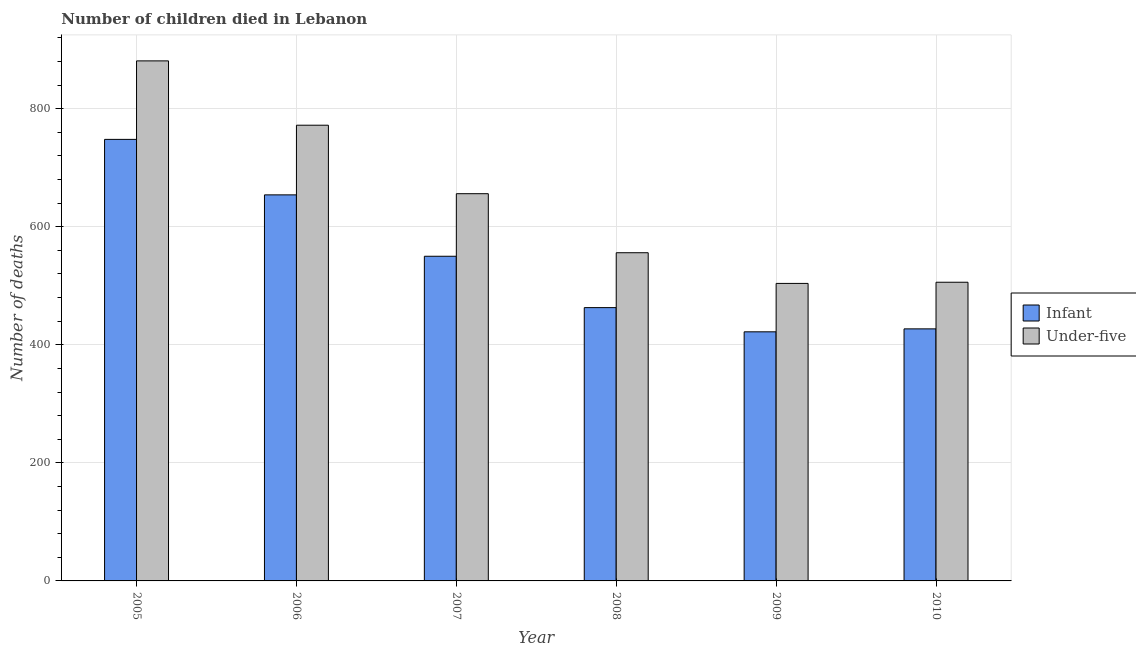How many groups of bars are there?
Make the answer very short. 6. Are the number of bars per tick equal to the number of legend labels?
Make the answer very short. Yes. What is the number of infant deaths in 2010?
Make the answer very short. 427. Across all years, what is the maximum number of infant deaths?
Your answer should be compact. 748. Across all years, what is the minimum number of under-five deaths?
Make the answer very short. 504. In which year was the number of infant deaths maximum?
Your answer should be very brief. 2005. In which year was the number of infant deaths minimum?
Your answer should be very brief. 2009. What is the total number of under-five deaths in the graph?
Ensure brevity in your answer.  3875. What is the difference between the number of infant deaths in 2005 and that in 2007?
Offer a very short reply. 198. What is the difference between the number of under-five deaths in 2010 and the number of infant deaths in 2007?
Ensure brevity in your answer.  -150. What is the average number of infant deaths per year?
Offer a very short reply. 544. In the year 2010, what is the difference between the number of infant deaths and number of under-five deaths?
Provide a short and direct response. 0. What is the ratio of the number of under-five deaths in 2005 to that in 2008?
Your response must be concise. 1.58. Is the number of under-five deaths in 2006 less than that in 2010?
Your response must be concise. No. What is the difference between the highest and the second highest number of infant deaths?
Keep it short and to the point. 94. What is the difference between the highest and the lowest number of under-five deaths?
Provide a short and direct response. 377. What does the 1st bar from the left in 2006 represents?
Offer a terse response. Infant. What does the 2nd bar from the right in 2008 represents?
Your answer should be very brief. Infant. What is the difference between two consecutive major ticks on the Y-axis?
Make the answer very short. 200. What is the title of the graph?
Make the answer very short. Number of children died in Lebanon. What is the label or title of the X-axis?
Ensure brevity in your answer.  Year. What is the label or title of the Y-axis?
Provide a succinct answer. Number of deaths. What is the Number of deaths in Infant in 2005?
Offer a very short reply. 748. What is the Number of deaths of Under-five in 2005?
Provide a succinct answer. 881. What is the Number of deaths in Infant in 2006?
Offer a terse response. 654. What is the Number of deaths in Under-five in 2006?
Ensure brevity in your answer.  772. What is the Number of deaths of Infant in 2007?
Offer a very short reply. 550. What is the Number of deaths in Under-five in 2007?
Make the answer very short. 656. What is the Number of deaths in Infant in 2008?
Offer a terse response. 463. What is the Number of deaths in Under-five in 2008?
Offer a very short reply. 556. What is the Number of deaths in Infant in 2009?
Provide a short and direct response. 422. What is the Number of deaths in Under-five in 2009?
Provide a succinct answer. 504. What is the Number of deaths of Infant in 2010?
Your answer should be compact. 427. What is the Number of deaths in Under-five in 2010?
Your response must be concise. 506. Across all years, what is the maximum Number of deaths in Infant?
Your answer should be very brief. 748. Across all years, what is the maximum Number of deaths of Under-five?
Ensure brevity in your answer.  881. Across all years, what is the minimum Number of deaths in Infant?
Your answer should be compact. 422. Across all years, what is the minimum Number of deaths of Under-five?
Provide a succinct answer. 504. What is the total Number of deaths of Infant in the graph?
Offer a very short reply. 3264. What is the total Number of deaths in Under-five in the graph?
Make the answer very short. 3875. What is the difference between the Number of deaths of Infant in 2005 and that in 2006?
Your answer should be compact. 94. What is the difference between the Number of deaths in Under-five in 2005 and that in 2006?
Keep it short and to the point. 109. What is the difference between the Number of deaths of Infant in 2005 and that in 2007?
Offer a very short reply. 198. What is the difference between the Number of deaths in Under-five in 2005 and that in 2007?
Your answer should be very brief. 225. What is the difference between the Number of deaths in Infant in 2005 and that in 2008?
Give a very brief answer. 285. What is the difference between the Number of deaths of Under-five in 2005 and that in 2008?
Provide a succinct answer. 325. What is the difference between the Number of deaths of Infant in 2005 and that in 2009?
Ensure brevity in your answer.  326. What is the difference between the Number of deaths in Under-five in 2005 and that in 2009?
Give a very brief answer. 377. What is the difference between the Number of deaths of Infant in 2005 and that in 2010?
Your answer should be very brief. 321. What is the difference between the Number of deaths of Under-five in 2005 and that in 2010?
Your answer should be compact. 375. What is the difference between the Number of deaths in Infant in 2006 and that in 2007?
Ensure brevity in your answer.  104. What is the difference between the Number of deaths in Under-five in 2006 and that in 2007?
Your answer should be very brief. 116. What is the difference between the Number of deaths in Infant in 2006 and that in 2008?
Offer a very short reply. 191. What is the difference between the Number of deaths of Under-five in 2006 and that in 2008?
Provide a succinct answer. 216. What is the difference between the Number of deaths in Infant in 2006 and that in 2009?
Your response must be concise. 232. What is the difference between the Number of deaths in Under-five in 2006 and that in 2009?
Your response must be concise. 268. What is the difference between the Number of deaths in Infant in 2006 and that in 2010?
Make the answer very short. 227. What is the difference between the Number of deaths in Under-five in 2006 and that in 2010?
Keep it short and to the point. 266. What is the difference between the Number of deaths in Under-five in 2007 and that in 2008?
Give a very brief answer. 100. What is the difference between the Number of deaths of Infant in 2007 and that in 2009?
Provide a short and direct response. 128. What is the difference between the Number of deaths in Under-five in 2007 and that in 2009?
Keep it short and to the point. 152. What is the difference between the Number of deaths in Infant in 2007 and that in 2010?
Your answer should be very brief. 123. What is the difference between the Number of deaths in Under-five in 2007 and that in 2010?
Provide a short and direct response. 150. What is the difference between the Number of deaths of Infant in 2008 and that in 2010?
Ensure brevity in your answer.  36. What is the difference between the Number of deaths in Under-five in 2008 and that in 2010?
Provide a short and direct response. 50. What is the difference between the Number of deaths in Under-five in 2009 and that in 2010?
Keep it short and to the point. -2. What is the difference between the Number of deaths in Infant in 2005 and the Number of deaths in Under-five in 2007?
Your response must be concise. 92. What is the difference between the Number of deaths in Infant in 2005 and the Number of deaths in Under-five in 2008?
Your answer should be very brief. 192. What is the difference between the Number of deaths of Infant in 2005 and the Number of deaths of Under-five in 2009?
Provide a short and direct response. 244. What is the difference between the Number of deaths in Infant in 2005 and the Number of deaths in Under-five in 2010?
Offer a terse response. 242. What is the difference between the Number of deaths of Infant in 2006 and the Number of deaths of Under-five in 2007?
Your response must be concise. -2. What is the difference between the Number of deaths of Infant in 2006 and the Number of deaths of Under-five in 2008?
Keep it short and to the point. 98. What is the difference between the Number of deaths in Infant in 2006 and the Number of deaths in Under-five in 2009?
Offer a very short reply. 150. What is the difference between the Number of deaths of Infant in 2006 and the Number of deaths of Under-five in 2010?
Give a very brief answer. 148. What is the difference between the Number of deaths of Infant in 2007 and the Number of deaths of Under-five in 2008?
Your response must be concise. -6. What is the difference between the Number of deaths of Infant in 2008 and the Number of deaths of Under-five in 2009?
Your answer should be very brief. -41. What is the difference between the Number of deaths of Infant in 2008 and the Number of deaths of Under-five in 2010?
Your answer should be very brief. -43. What is the difference between the Number of deaths of Infant in 2009 and the Number of deaths of Under-five in 2010?
Make the answer very short. -84. What is the average Number of deaths of Infant per year?
Provide a succinct answer. 544. What is the average Number of deaths in Under-five per year?
Make the answer very short. 645.83. In the year 2005, what is the difference between the Number of deaths of Infant and Number of deaths of Under-five?
Offer a terse response. -133. In the year 2006, what is the difference between the Number of deaths of Infant and Number of deaths of Under-five?
Your answer should be compact. -118. In the year 2007, what is the difference between the Number of deaths in Infant and Number of deaths in Under-five?
Your answer should be compact. -106. In the year 2008, what is the difference between the Number of deaths in Infant and Number of deaths in Under-five?
Your answer should be compact. -93. In the year 2009, what is the difference between the Number of deaths in Infant and Number of deaths in Under-five?
Make the answer very short. -82. In the year 2010, what is the difference between the Number of deaths of Infant and Number of deaths of Under-five?
Your answer should be compact. -79. What is the ratio of the Number of deaths in Infant in 2005 to that in 2006?
Your answer should be compact. 1.14. What is the ratio of the Number of deaths of Under-five in 2005 to that in 2006?
Ensure brevity in your answer.  1.14. What is the ratio of the Number of deaths of Infant in 2005 to that in 2007?
Keep it short and to the point. 1.36. What is the ratio of the Number of deaths of Under-five in 2005 to that in 2007?
Provide a succinct answer. 1.34. What is the ratio of the Number of deaths of Infant in 2005 to that in 2008?
Keep it short and to the point. 1.62. What is the ratio of the Number of deaths of Under-five in 2005 to that in 2008?
Provide a succinct answer. 1.58. What is the ratio of the Number of deaths in Infant in 2005 to that in 2009?
Make the answer very short. 1.77. What is the ratio of the Number of deaths in Under-five in 2005 to that in 2009?
Offer a very short reply. 1.75. What is the ratio of the Number of deaths of Infant in 2005 to that in 2010?
Keep it short and to the point. 1.75. What is the ratio of the Number of deaths in Under-five in 2005 to that in 2010?
Keep it short and to the point. 1.74. What is the ratio of the Number of deaths in Infant in 2006 to that in 2007?
Offer a terse response. 1.19. What is the ratio of the Number of deaths of Under-five in 2006 to that in 2007?
Offer a terse response. 1.18. What is the ratio of the Number of deaths of Infant in 2006 to that in 2008?
Give a very brief answer. 1.41. What is the ratio of the Number of deaths in Under-five in 2006 to that in 2008?
Ensure brevity in your answer.  1.39. What is the ratio of the Number of deaths in Infant in 2006 to that in 2009?
Ensure brevity in your answer.  1.55. What is the ratio of the Number of deaths in Under-five in 2006 to that in 2009?
Ensure brevity in your answer.  1.53. What is the ratio of the Number of deaths of Infant in 2006 to that in 2010?
Ensure brevity in your answer.  1.53. What is the ratio of the Number of deaths of Under-five in 2006 to that in 2010?
Offer a very short reply. 1.53. What is the ratio of the Number of deaths in Infant in 2007 to that in 2008?
Provide a succinct answer. 1.19. What is the ratio of the Number of deaths of Under-five in 2007 to that in 2008?
Make the answer very short. 1.18. What is the ratio of the Number of deaths of Infant in 2007 to that in 2009?
Make the answer very short. 1.3. What is the ratio of the Number of deaths in Under-five in 2007 to that in 2009?
Your response must be concise. 1.3. What is the ratio of the Number of deaths of Infant in 2007 to that in 2010?
Provide a short and direct response. 1.29. What is the ratio of the Number of deaths in Under-five in 2007 to that in 2010?
Your answer should be very brief. 1.3. What is the ratio of the Number of deaths of Infant in 2008 to that in 2009?
Make the answer very short. 1.1. What is the ratio of the Number of deaths of Under-five in 2008 to that in 2009?
Ensure brevity in your answer.  1.1. What is the ratio of the Number of deaths of Infant in 2008 to that in 2010?
Offer a very short reply. 1.08. What is the ratio of the Number of deaths of Under-five in 2008 to that in 2010?
Keep it short and to the point. 1.1. What is the ratio of the Number of deaths of Infant in 2009 to that in 2010?
Your response must be concise. 0.99. What is the ratio of the Number of deaths of Under-five in 2009 to that in 2010?
Your answer should be compact. 1. What is the difference between the highest and the second highest Number of deaths in Infant?
Provide a succinct answer. 94. What is the difference between the highest and the second highest Number of deaths of Under-five?
Your response must be concise. 109. What is the difference between the highest and the lowest Number of deaths in Infant?
Offer a terse response. 326. What is the difference between the highest and the lowest Number of deaths of Under-five?
Keep it short and to the point. 377. 